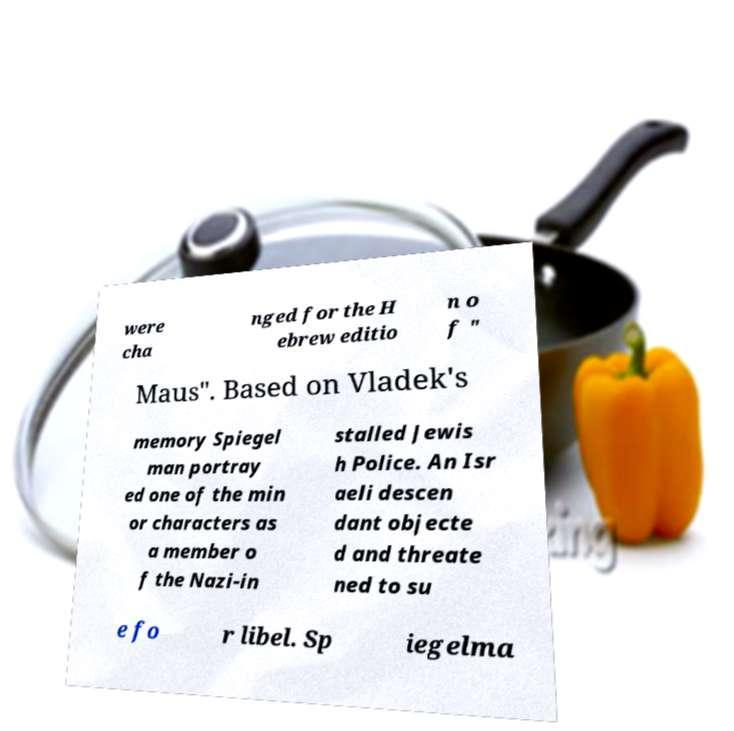Can you read and provide the text displayed in the image?This photo seems to have some interesting text. Can you extract and type it out for me? were cha nged for the H ebrew editio n o f " Maus". Based on Vladek's memory Spiegel man portray ed one of the min or characters as a member o f the Nazi-in stalled Jewis h Police. An Isr aeli descen dant objecte d and threate ned to su e fo r libel. Sp iegelma 